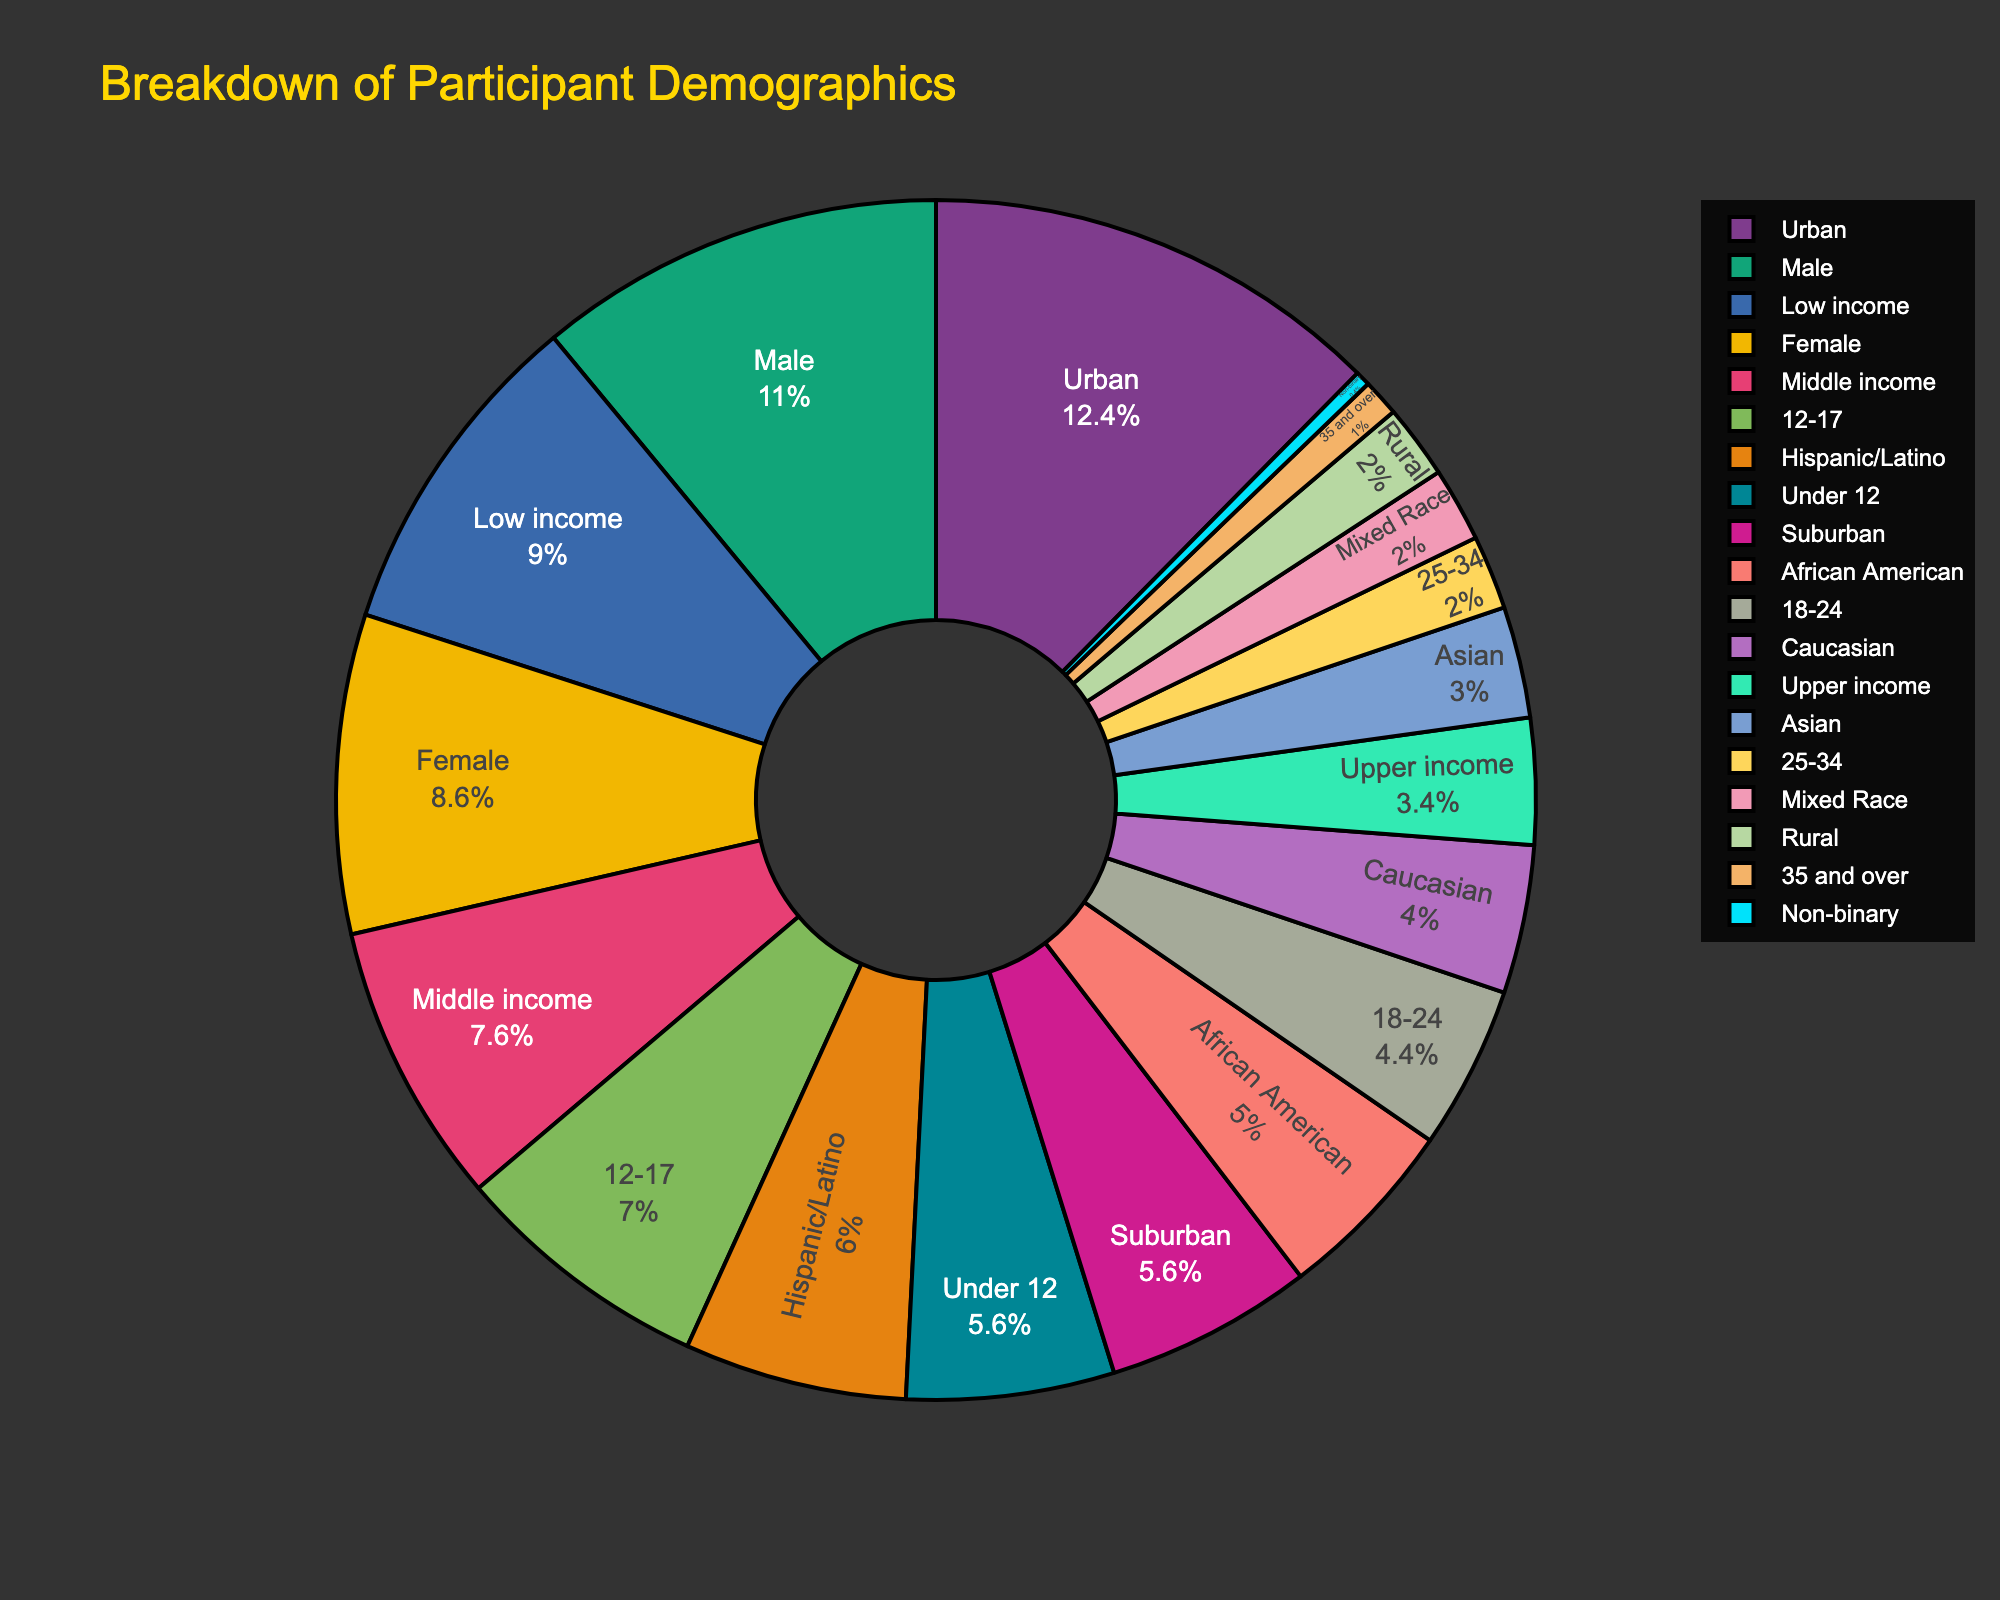What is the largest age group represented in the soccer outreach programs? The largest percentage in the Age Group category is 35%, which corresponds to the 12-17 age group.
Answer: 12-17 How does the percentage of participants from low-income backgrounds compare to those from middle-income backgrounds? The percentage of participants from low-income backgrounds is 45%, while those from middle-income backgrounds is 38%. 45% is greater than 38%.
Answer: Greater What is the combined percentage of female and non-binary participants? The percentage of female participants is 43%, and non-binary participants is 2%. Summing these, 43% + 2% = 45%.
Answer: 45% Which ethnic group has the smallest representation? Comparing ethnic groups, the percentages are: Hispanic/Latino 30%, African American 25%, Caucasian 20%, Asian 15%, Mixed Race 10%. The smallest is Mixed Race with 10%.
Answer: Mixed Race By how much does the percentage of urban participants exceed the combined percentage of suburban and rural participants? Urban participants are 62%, suburban are 28%, and rural are 10%. Combined suburban and rural is 28% + 10% = 38%. Difference is 62% - 38% = 24%.
Answer: 24% Is the percentage of male participants greater than the total of participants over 25 years? The percentage of male participants is 55%. Participants over 25 years include 25-34 (10%) and 35 and over (5%). Summing these, 10% + 5% = 15%. 55% is greater than 15%.
Answer: Yes What portion of the total demographic consists of participants aged 18-24 and non-binary participants? The percentage of participants aged 18-24 is 22%; non-binary participants are 2%. Summing these, 22% + 2% = 24%.
Answer: 24% Which location type has the least percentage of participants, and what is this percentage? The percentages are 62% urban, 28% suburban, and 10% rural. The least is rural with 10%.
Answer: Rural, 10% How does the representation of male participants compare to that of Hispanic/Latino participants? The percentage of male participants is 55% and Hispanic/Latino participants is 30%. 55% is greater than 30%.
Answer: Greater What is the difference between the highest and lowest percentages in the Age Group category? The highest percentage in the Age Group category is 35% (12-17) and the lowest is 5% (35 and over). The difference is 35% - 5% = 30%.
Answer: 30% 